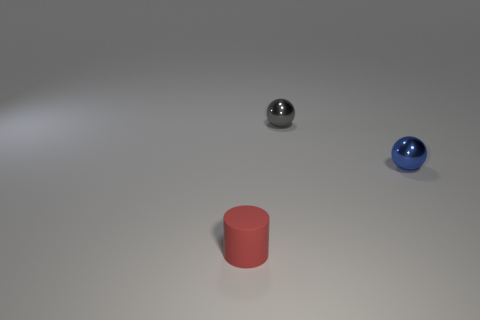Is there any indication of what the blue ball's purpose might be? Based on the image alone, there is no specific context provided that would indicate the blue ball's purpose. It could be a simple decorative object, a part of a game or toy, or a tool for an activity not depicted within the frame of the image. 